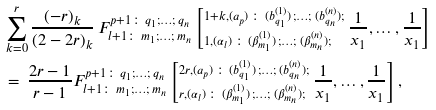Convert formula to latex. <formula><loc_0><loc_0><loc_500><loc_500>& \sum _ { k = 0 } ^ { r } \frac { ( - r ) _ { k } } { ( 2 - 2 r ) _ { k } } \, F _ { { l + 1 } \colon \, m _ { 1 } ; \dots ; \, m _ { n } } ^ { p + 1 \colon \, q _ { 1 } ; \dots ; \, q _ { n } } \left [ ^ { 1 + k , ( a _ { p } ) \, \colon \, ( b ^ { ( 1 ) } _ { q _ { 1 } } ) \, ; \dots ; \, ( b ^ { ( n ) } _ { q _ { n } } ) ; } _ { 1 , ( \alpha _ { l } ) \, \colon \, ( \beta ^ { ( 1 ) } _ { m _ { 1 } } ) \, ; \dots ; \, ( \beta ^ { ( n ) } _ { m _ { n } } ) ; } \, \frac { 1 } { x _ { 1 } } , \dots , \frac { 1 } { x _ { 1 } } \right ] \\ & = \, \frac { 2 r - 1 } { r - 1 } F _ { { l + 1 } \colon \, m _ { 1 } ; \dots ; \, m _ { n } } ^ { p + 1 \colon \, q _ { 1 } ; \dots ; \, q _ { n } } \left [ ^ { 2 r , ( a _ { p } ) \, \colon \, ( b ^ { ( 1 ) } _ { q _ { 1 } } ) \, ; \dots ; \, ( b ^ { ( n ) } _ { q _ { n } } ) ; } _ { r , ( \alpha _ { l } ) \, \colon \, ( \beta ^ { ( 1 ) } _ { m _ { 1 } } ) \, ; \dots ; \, ( \beta ^ { ( n ) } _ { m _ { n } } ) ; } \, \frac { 1 } { x _ { 1 } } , \dots , \frac { 1 } { x _ { 1 } } \right ] ,</formula> 